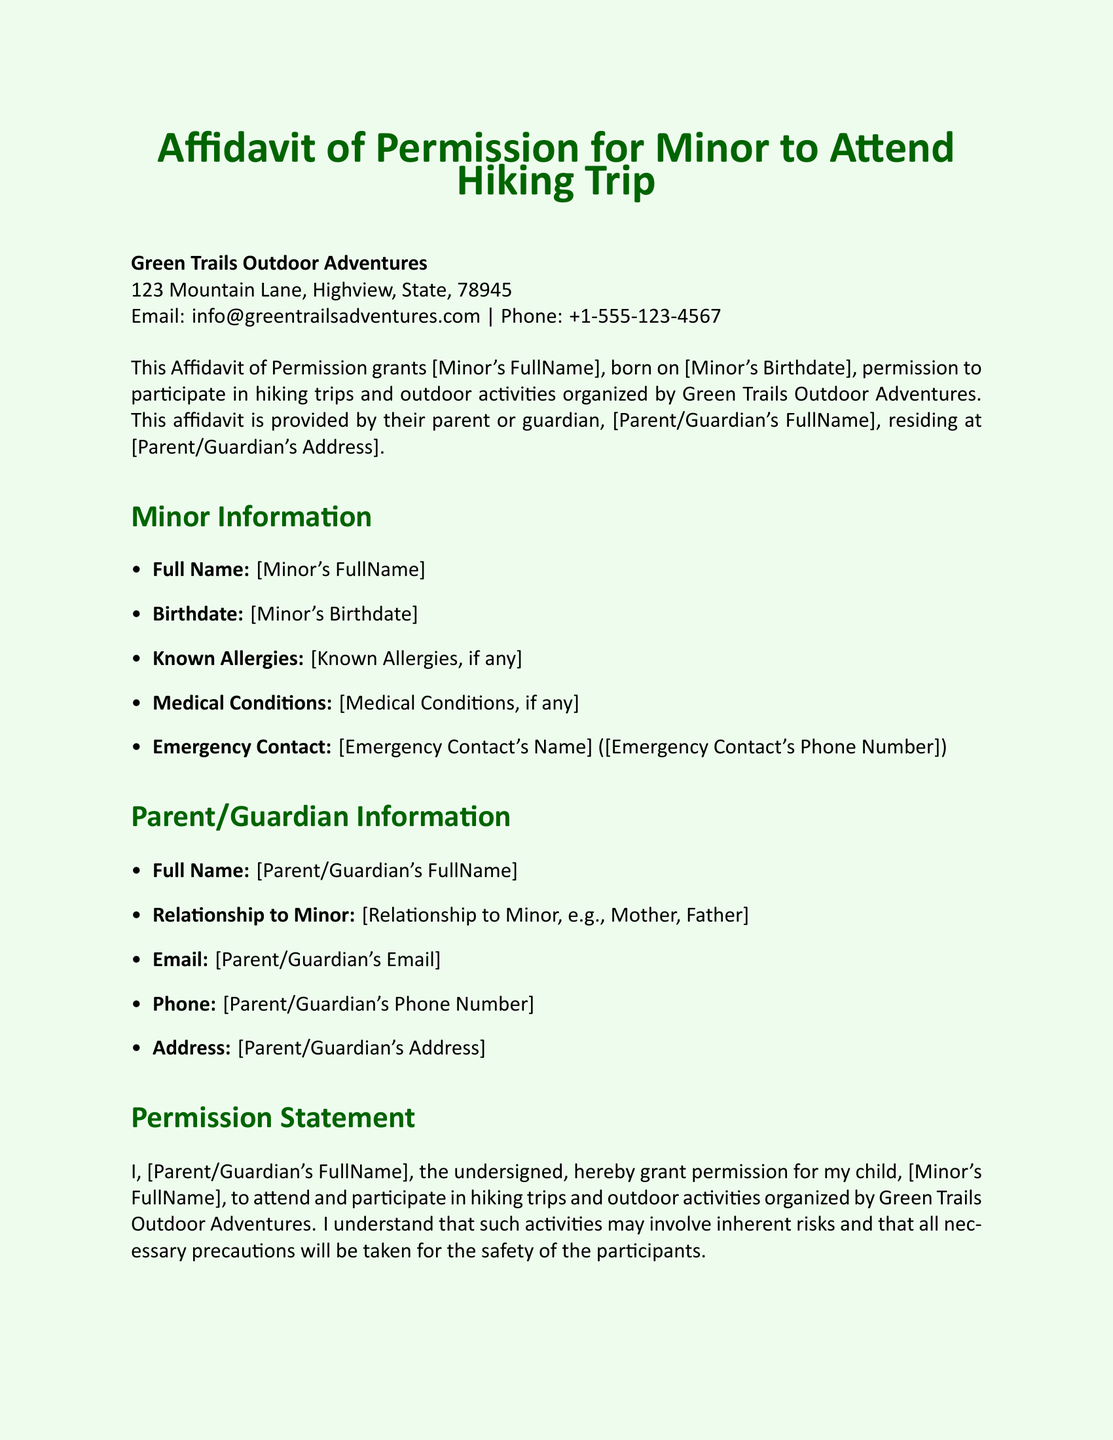What is the name of the organization? The organization that the affidavit is addressed to is Green Trails Outdoor Adventures.
Answer: Green Trails Outdoor Adventures What is the emergency contact's name? This information is provided under the Minor Information section of the document, specifically as the Emergency Contact's Name.
Answer: [Emergency Contact's Name] Who provides the affidavit? The affidavit is provided by the parent or guardian of the minor, as mentioned in the introductory statement.
Answer: Parent or Guardian What is the minor's birthdate placeholder? The minor's birthdate is noted in the Minor Information section, which is represented as [Minor's Birthdate].
Answer: [Minor's Birthdate] What does the parent acknowledge by signing? The parent acknowledges and accepts that the organization is not liable for injuries or damages, as stated in the Liability Release section.
Answer: Liability acceptance What is the address of the organization? The address of the organization is listed under their contact details at the beginning of the document.
Answer: 123 Mountain Lane, Highview, State, 78945 How must the minor's name be inputted? The minor's name is indicated in the document as needing to be entered in the format of [Minor's FullName].
Answer: [Minor's FullName] What is the consequence of non-disclosure of health concerns? The document indicates that the parent should inform the organizers of health concerns, implying responsibility for any issues that arise.
Answer: Responsibility for issues Who signs the affidavit along with the parent/guardian? The notary public also signs the affidavit to validate it, as indicated in the signature section.
Answer: Notary Public 